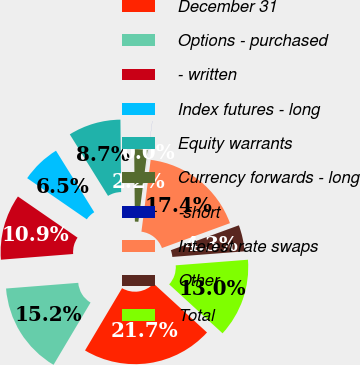<chart> <loc_0><loc_0><loc_500><loc_500><pie_chart><fcel>December 31<fcel>Options - purchased<fcel>- written<fcel>Index futures - long<fcel>Equity warrants<fcel>Currency forwards - long<fcel>-short<fcel>Interest rate swaps<fcel>Other<fcel>Total<nl><fcel>21.73%<fcel>15.21%<fcel>10.87%<fcel>6.53%<fcel>8.7%<fcel>2.18%<fcel>0.01%<fcel>17.38%<fcel>4.35%<fcel>13.04%<nl></chart> 